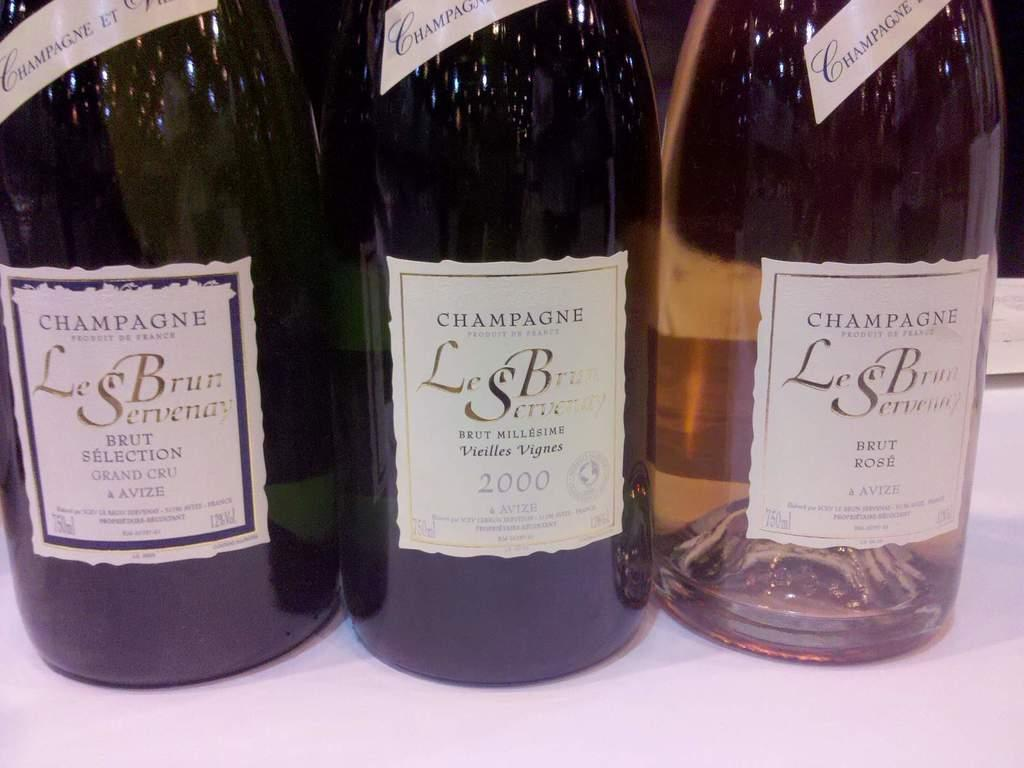<image>
Write a terse but informative summary of the picture. Three bottles of champagne are next to each other on a table and one of the bottles has the year 2000 on it. 